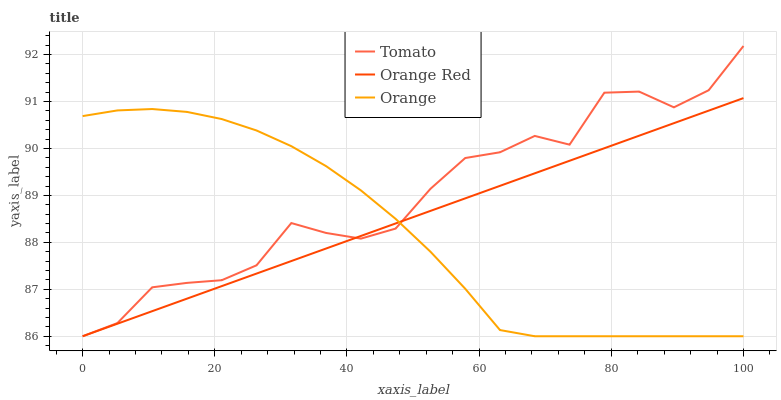Does Orange Red have the minimum area under the curve?
Answer yes or no. No. Does Orange Red have the maximum area under the curve?
Answer yes or no. No. Is Orange the smoothest?
Answer yes or no. No. Is Orange the roughest?
Answer yes or no. No. Does Orange Red have the highest value?
Answer yes or no. No. 